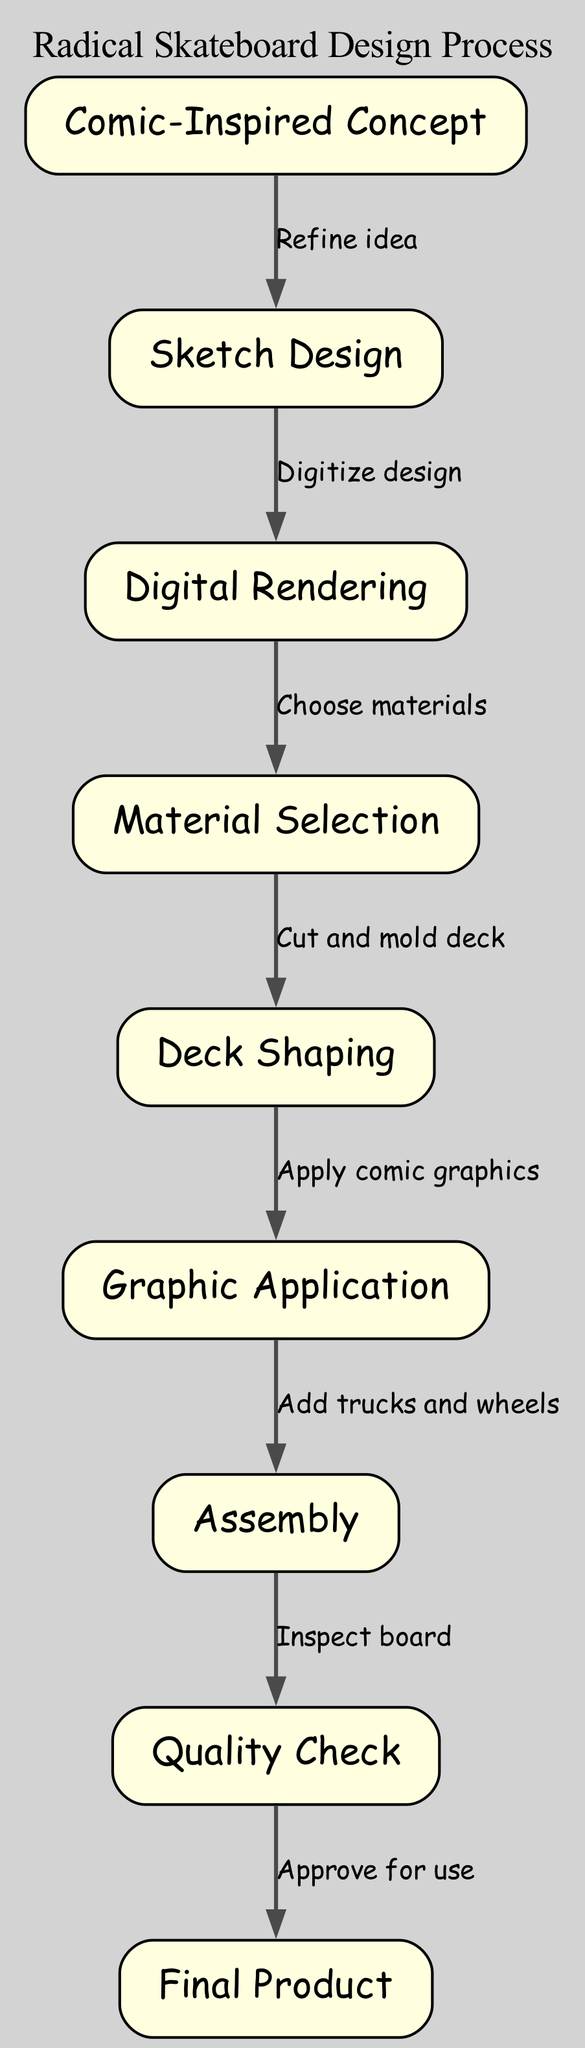What is the first step in the skateboard design process? The first step is labeled "Comic-Inspired Concept" in the diagram, which indicates the initial phase of the design process.
Answer: Comic-Inspired Concept How many nodes are present in the diagram? By counting the nodes listed in the data section, we find there are 9 nodes in total, each representing a distinct phase of the process.
Answer: 9 What is the label on the edge connecting sketch design to digital rendering? The edge connecting these two nodes is labeled "Digitize design," which explains the relationship between the two steps in the process.
Answer: Digitize design Which node follows the graphic application node in the process? The node that follows "Graphic Application" is "Assembly." This indicates the sequence, where the application of graphics leads directly to the assembly of the skateboard.
Answer: Assembly What is the last stage before the final product is approved for use? The stage before the final product is "Quality Check," where the skateboard is inspected to ensure it meets the required standards before approval.
Answer: Quality Check How many edges are used in the diagram? The edges in the diagram are defined by the connections between nodes in the flowchart, and there are a total of 8 edges as outlined in the data.
Answer: 8 What does the edge labeled "Refine idea" connect? The edge labeled "Refine idea" connects "Comic-Inspired Concept" to "Sketch Design," indicating that the idea is refined before moving on to the sketch stage.
Answer: Comic-Inspired Concept to Sketch Design Which step involves choosing materials? The step that involves choosing materials is labeled "Material Selection," which comes after the digital rendering of the skateboard design.
Answer: Material Selection What comes immediately after deck shaping in the process? Immediately after "Deck Shaping," the next step is "Graphic Application," which involves applying the graphics to the shaped deck.
Answer: Graphic Application 